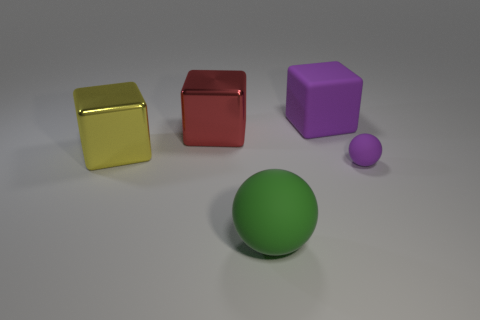Does the purple matte thing that is in front of the yellow block have the same size as the matte cube? The purple object, which appears to have a matte finish, is indeed smaller in size compared to the matte cube situated to the right of the yellow block when viewing the image. 